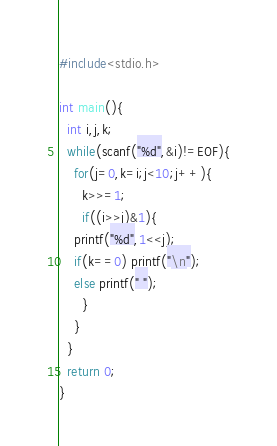Convert code to text. <code><loc_0><loc_0><loc_500><loc_500><_C_>#include<stdio.h>

int main(){
  int i,j,k;
  while(scanf("%d",&i)!=EOF){
    for(j=0,k=i;j<10;j++){
      k>>=1;
      if((i>>j)&1){
	printf("%d",1<<j);
	if(k==0) printf("\n");
	else printf(" ");
      }
    }
  }
  return 0;
}</code> 